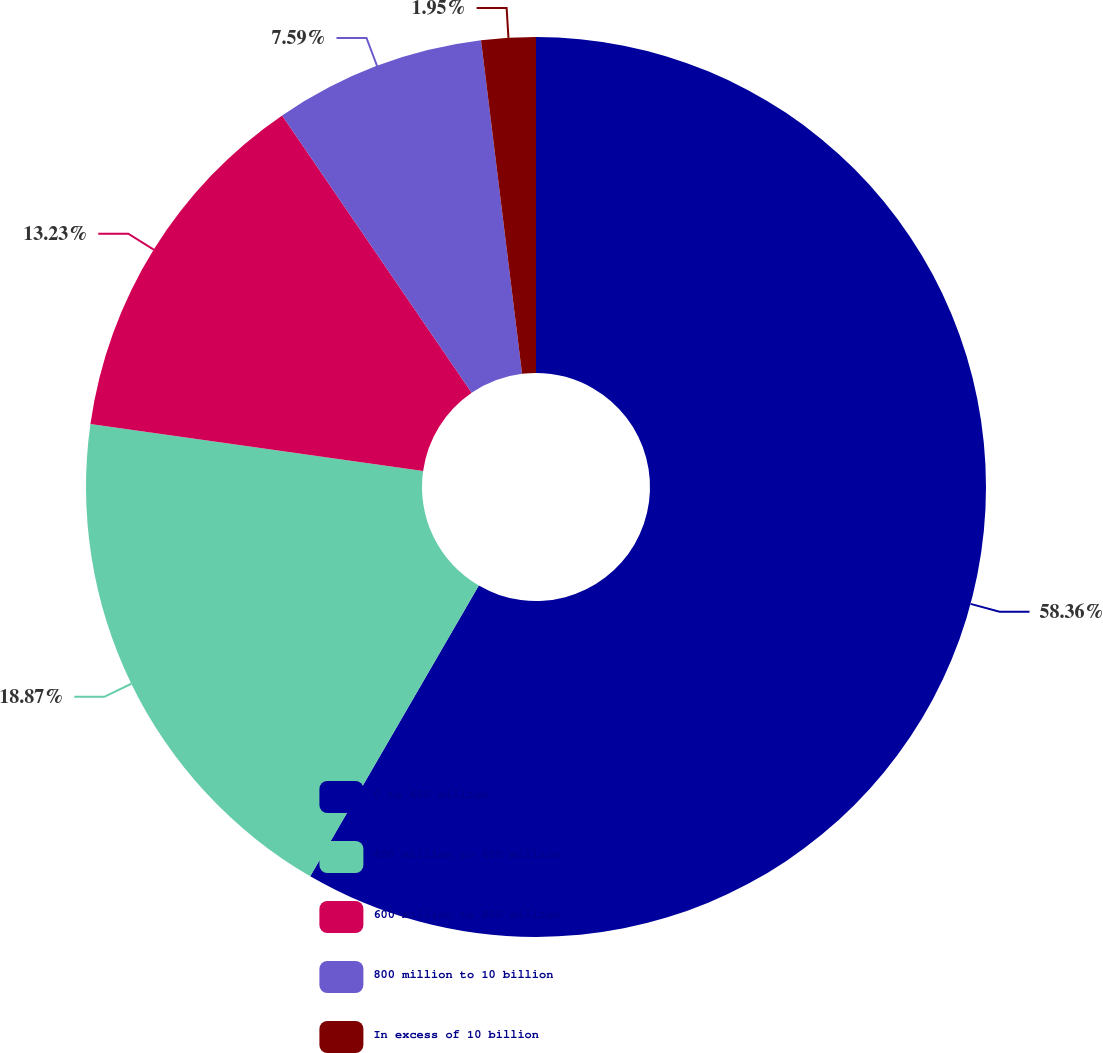Convert chart. <chart><loc_0><loc_0><loc_500><loc_500><pie_chart><fcel>0 to 400 million<fcel>400 million to 600 million<fcel>600 million to 800 million<fcel>800 million to 10 billion<fcel>In excess of 10 billion<nl><fcel>58.37%<fcel>18.87%<fcel>13.23%<fcel>7.59%<fcel>1.95%<nl></chart> 